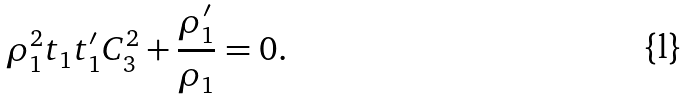<formula> <loc_0><loc_0><loc_500><loc_500>\rho _ { 1 } ^ { 2 } t _ { 1 } t _ { 1 } ^ { \prime } C _ { 3 } ^ { 2 } + \frac { \rho _ { 1 } ^ { \prime } } { \rho _ { 1 } } = 0 .</formula> 